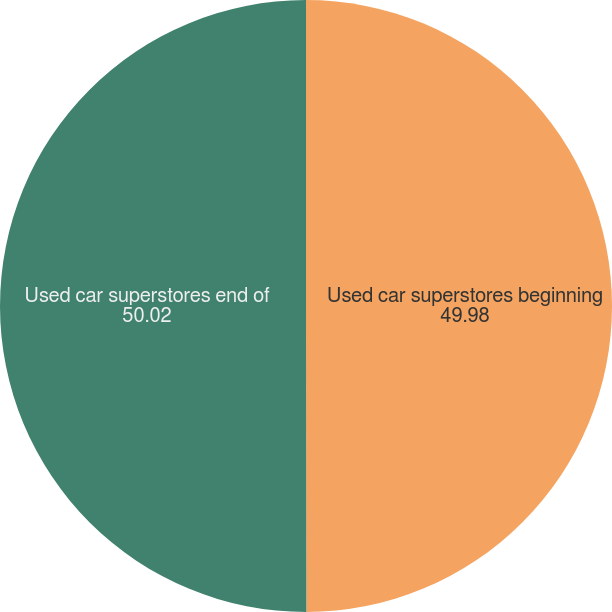<chart> <loc_0><loc_0><loc_500><loc_500><pie_chart><fcel>Used car superstores beginning<fcel>Used car superstores end of<nl><fcel>49.98%<fcel>50.02%<nl></chart> 